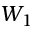Convert formula to latex. <formula><loc_0><loc_0><loc_500><loc_500>W _ { 1 }</formula> 